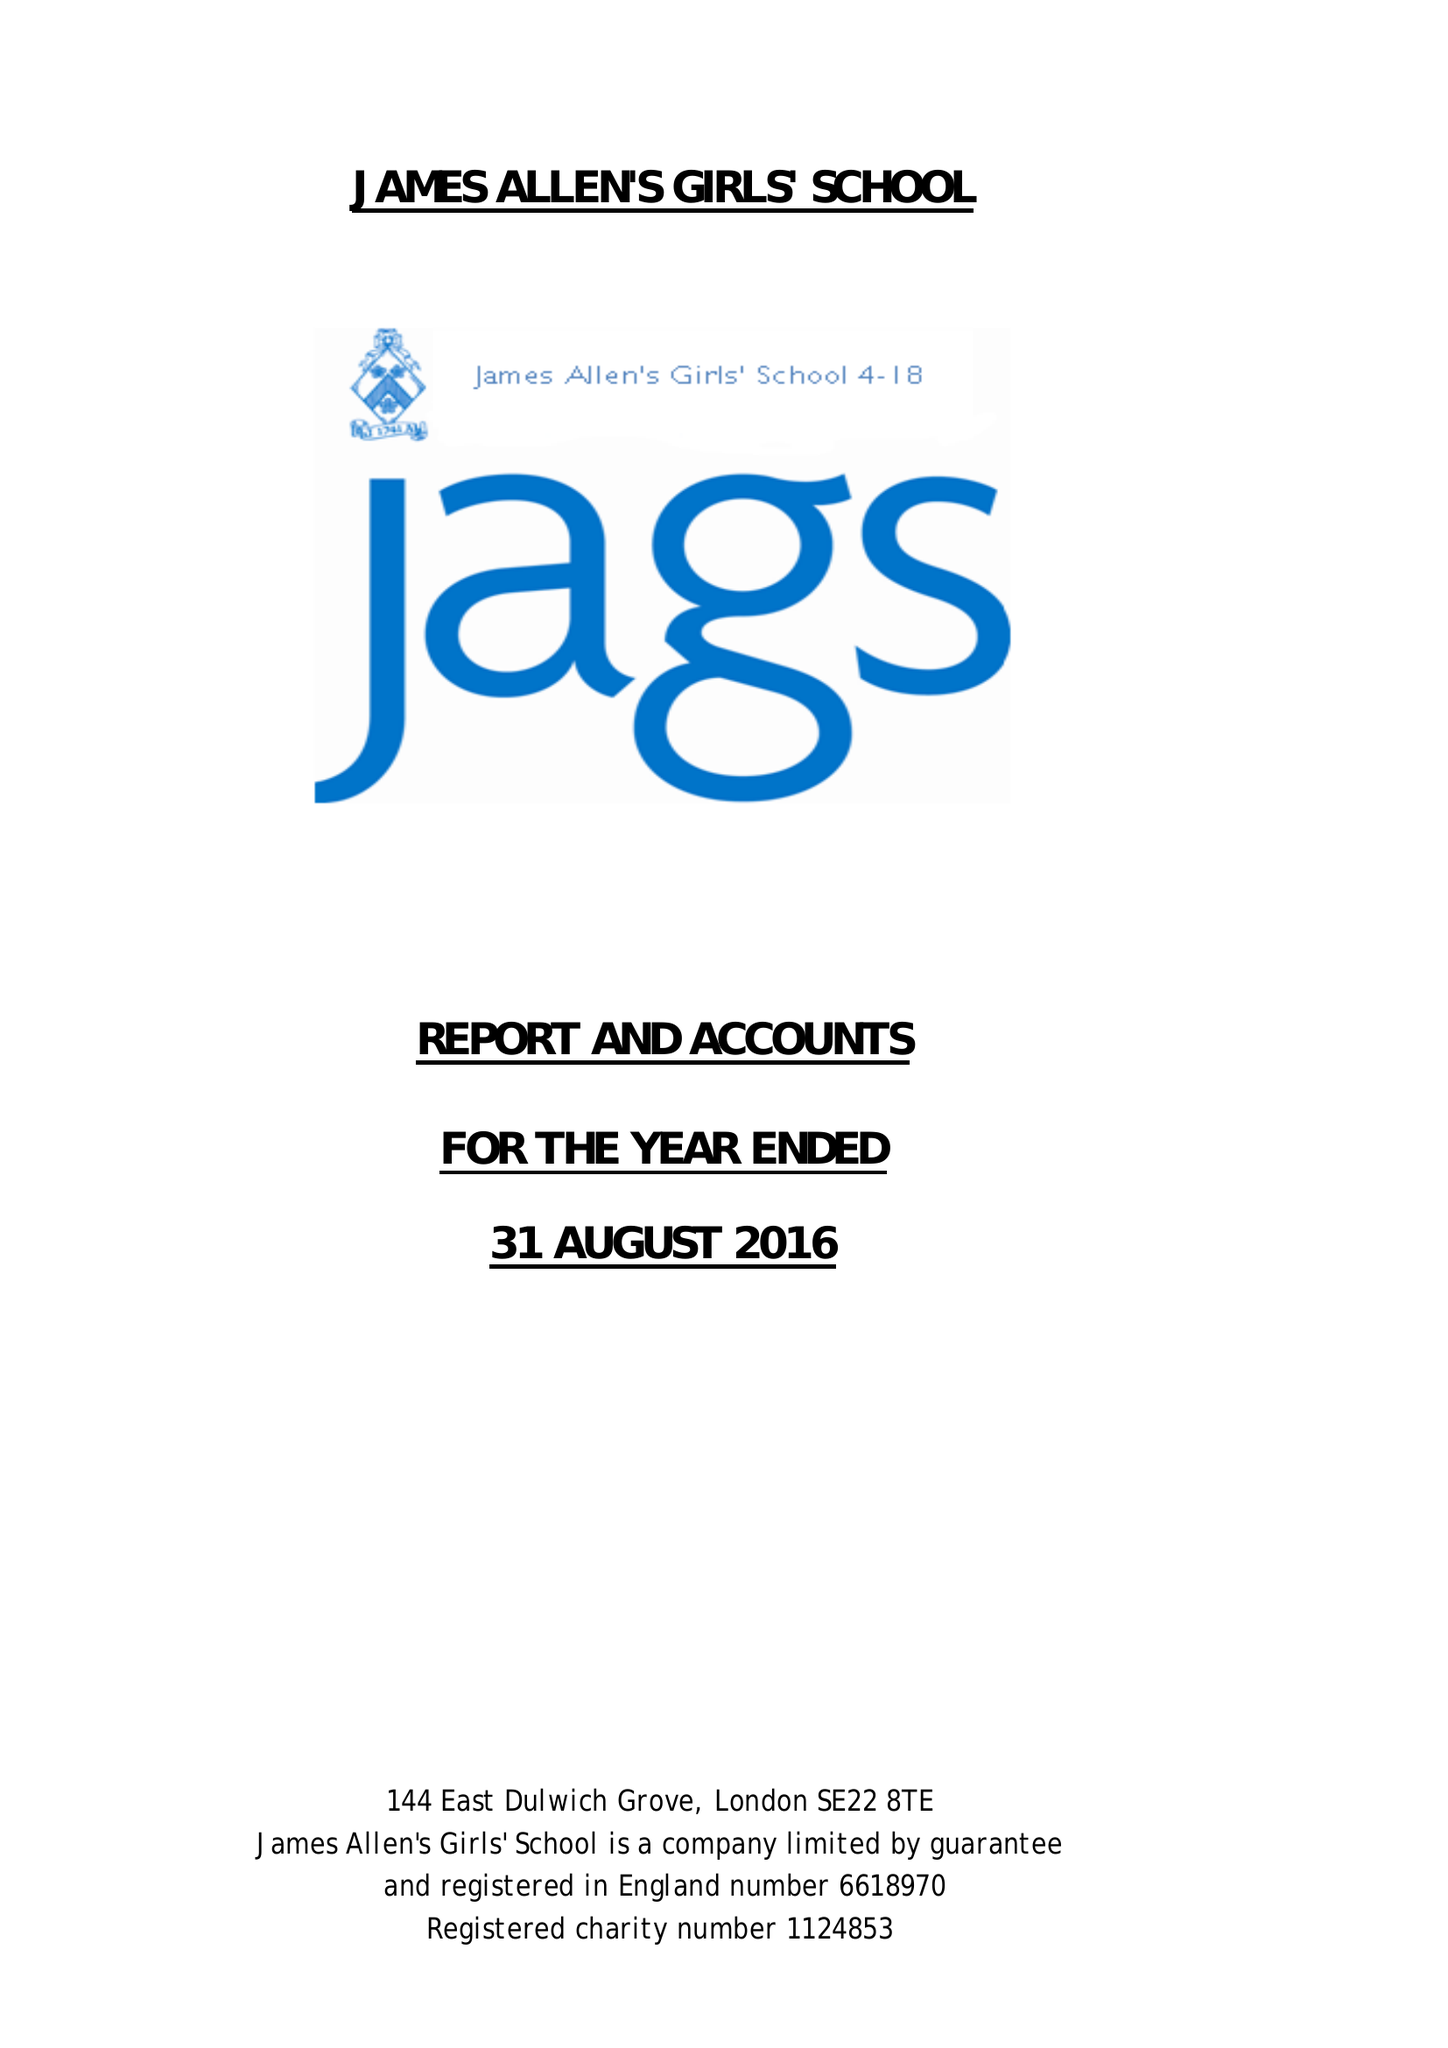What is the value for the income_annually_in_british_pounds?
Answer the question using a single word or phrase. 21144468.00 